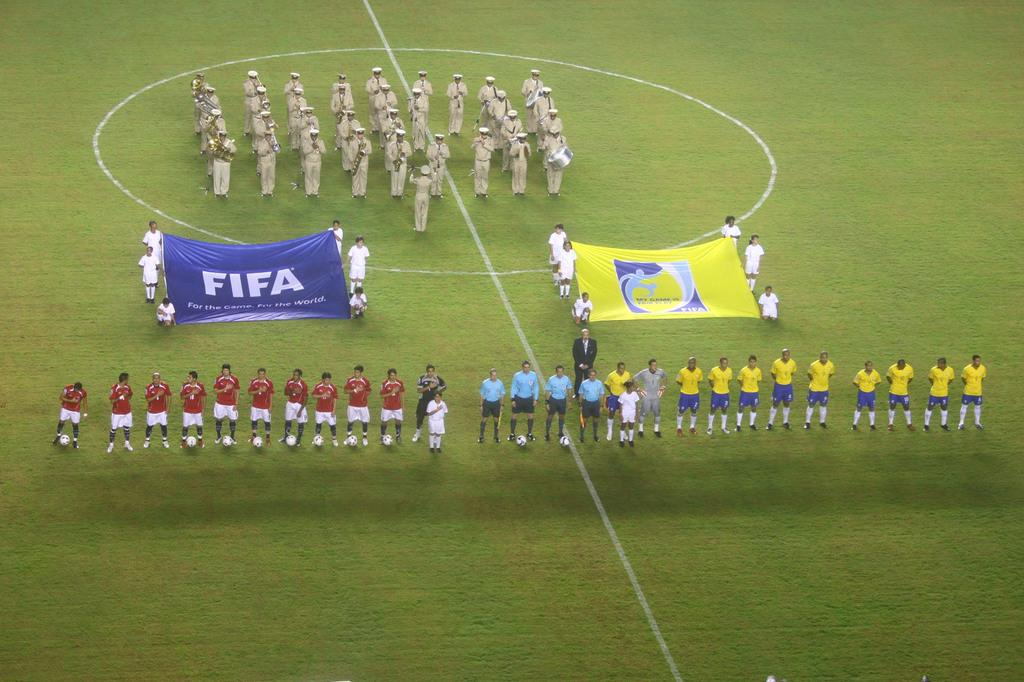<image>
Present a compact description of the photo's key features. Group of soccer players on the field holding a flag that says FIFA. 